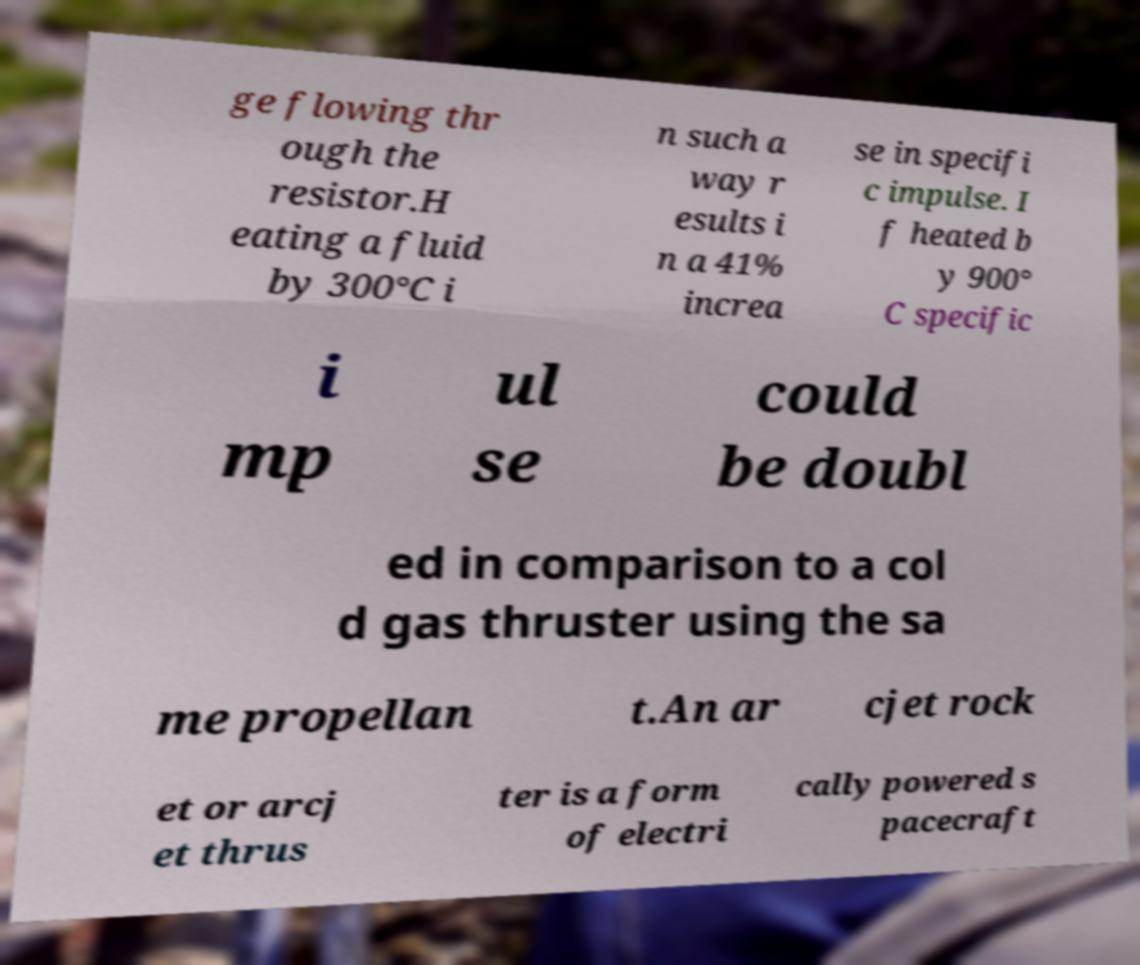Could you extract and type out the text from this image? ge flowing thr ough the resistor.H eating a fluid by 300°C i n such a way r esults i n a 41% increa se in specifi c impulse. I f heated b y 900° C specific i mp ul se could be doubl ed in comparison to a col d gas thruster using the sa me propellan t.An ar cjet rock et or arcj et thrus ter is a form of electri cally powered s pacecraft 